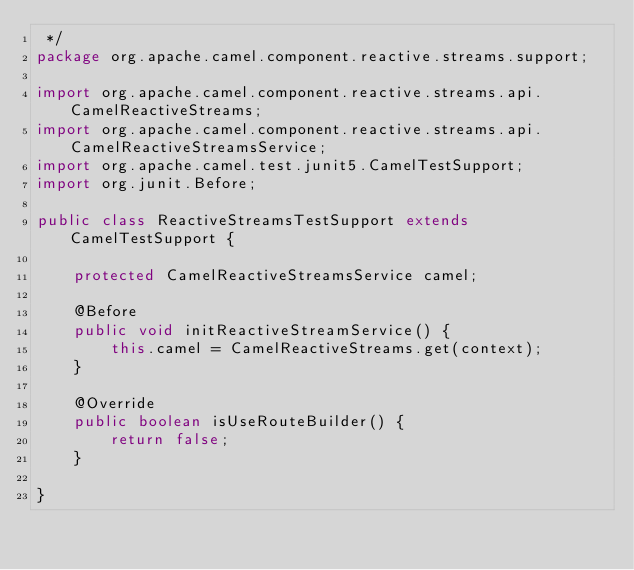<code> <loc_0><loc_0><loc_500><loc_500><_Java_> */
package org.apache.camel.component.reactive.streams.support;

import org.apache.camel.component.reactive.streams.api.CamelReactiveStreams;
import org.apache.camel.component.reactive.streams.api.CamelReactiveStreamsService;
import org.apache.camel.test.junit5.CamelTestSupport;
import org.junit.Before;

public class ReactiveStreamsTestSupport extends CamelTestSupport {

    protected CamelReactiveStreamsService camel;

    @Before
    public void initReactiveStreamService() {
        this.camel = CamelReactiveStreams.get(context);
    }

    @Override
    public boolean isUseRouteBuilder() {
        return false;
    }

}
</code> 